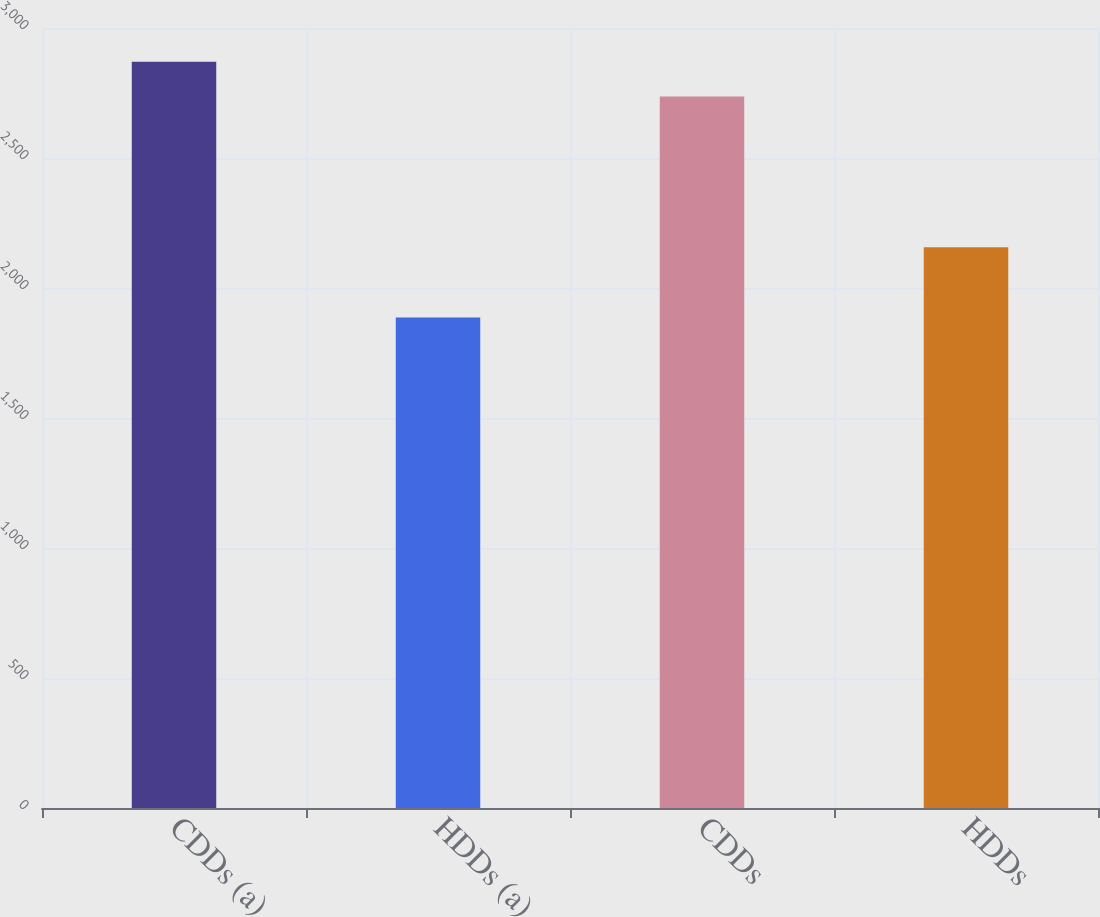Convert chart. <chart><loc_0><loc_0><loc_500><loc_500><bar_chart><fcel>CDDs (a)<fcel>HDDs (a)<fcel>CDDs<fcel>HDDs<nl><fcel>2870<fcel>1887<fcel>2737<fcel>2157<nl></chart> 